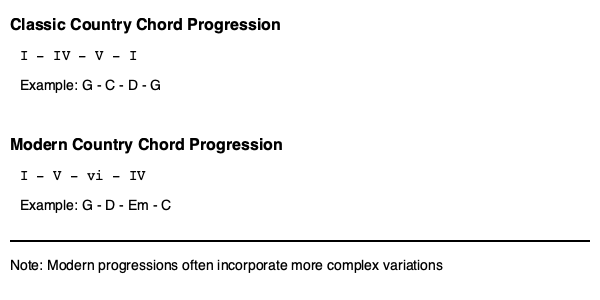Analyze the chord progressions shown for classic and modern country songs. Which progression is more likely to create a sense of resolution and finality, and why does this matter in the context of country music's evolution? To answer this question, we need to examine both chord progressions and their musical implications:

1. Classic Country Progression: I - IV - V - I
   - This is a traditional progression that follows the circle of fifths.
   - It starts on the tonic (I), moves to the subdominant (IV), then to the dominant (V), and resolves back to the tonic (I).
   - The V - I movement at the end creates a strong sense of resolution due to the dominant-tonic relationship.

2. Modern Country Progression: I - V - vi - IV
   - This progression is more commonly associated with pop music but has been adopted in modern country.
   - It starts on the tonic (I), moves to the dominant (V), then to the relative minor (vi), and ends on the subdominant (IV).
   - The progression doesn't end on the tonic, creating an "unresolved" feeling that can lead back to the beginning.

3. Comparison:
   - The classic progression has a stronger sense of resolution due to the V - I cadence at the end.
   - The modern progression has an "open" ending, which can create a more continuous, cyclical feel.

4. Implications for country music evolution:
   - The classic progression reflects traditional country's storytelling nature, often with clear beginnings and endings.
   - The modern progression aligns with contemporary pop influences, creating a more fluid, repeatable structure.
   - This shift represents country music's adaptation to modern pop sensibilities while retaining some traditional elements.

5. Importance in country music:
   - The change in chord progressions reflects broader shifts in song structure, lyrical content, and overall sound in country music.
   - It demonstrates how the genre has evolved to appeal to a wider, more mainstream audience while still maintaining its roots.
Answer: The classic I-IV-V-I progression creates a stronger sense of resolution, reflecting traditional country's narrative structure, while the modern I-V-vi-IV progression's open-ended nature aligns with contemporary pop influences, illustrating country music's evolution towards a more mainstream sound. 